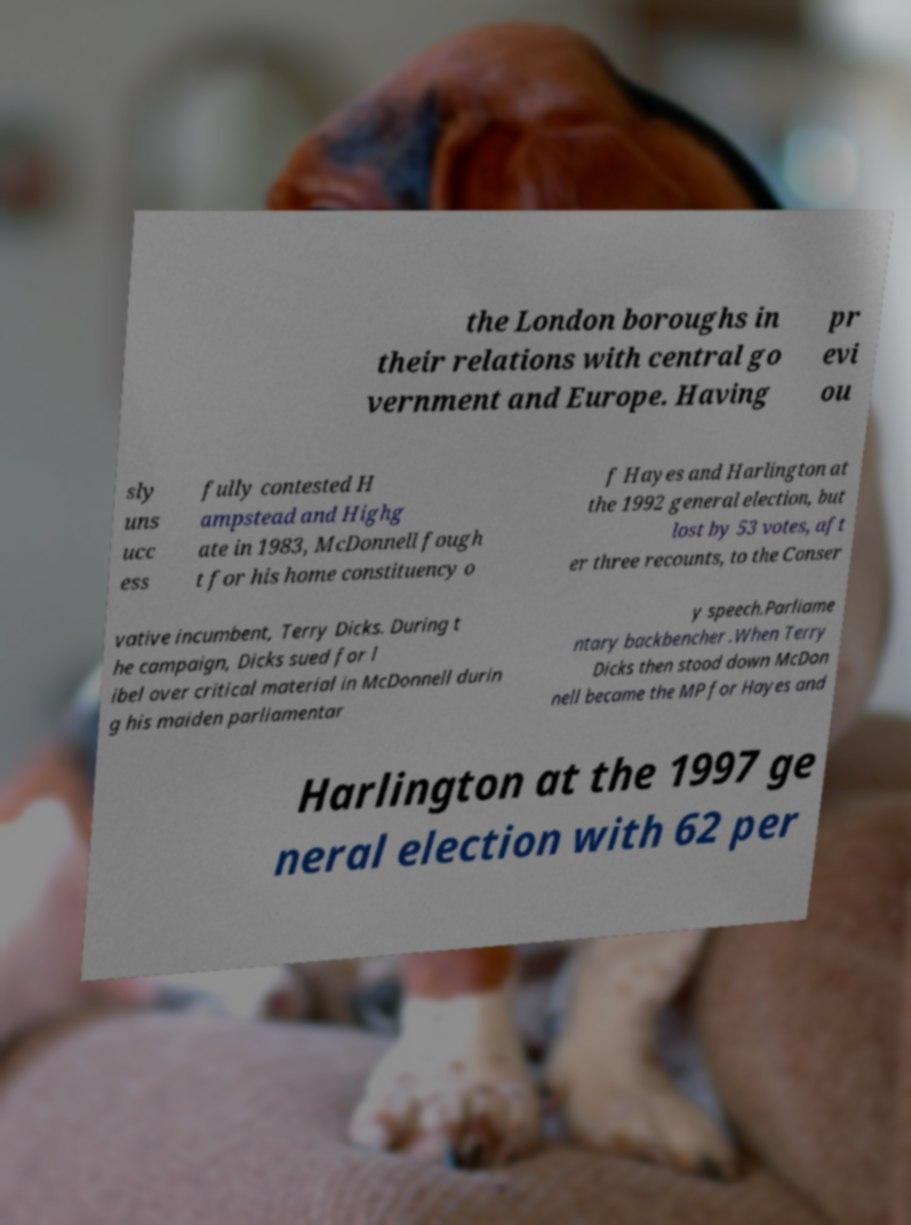Can you accurately transcribe the text from the provided image for me? the London boroughs in their relations with central go vernment and Europe. Having pr evi ou sly uns ucc ess fully contested H ampstead and Highg ate in 1983, McDonnell fough t for his home constituency o f Hayes and Harlington at the 1992 general election, but lost by 53 votes, aft er three recounts, to the Conser vative incumbent, Terry Dicks. During t he campaign, Dicks sued for l ibel over critical material in McDonnell durin g his maiden parliamentar y speech.Parliame ntary backbencher .When Terry Dicks then stood down McDon nell became the MP for Hayes and Harlington at the 1997 ge neral election with 62 per 